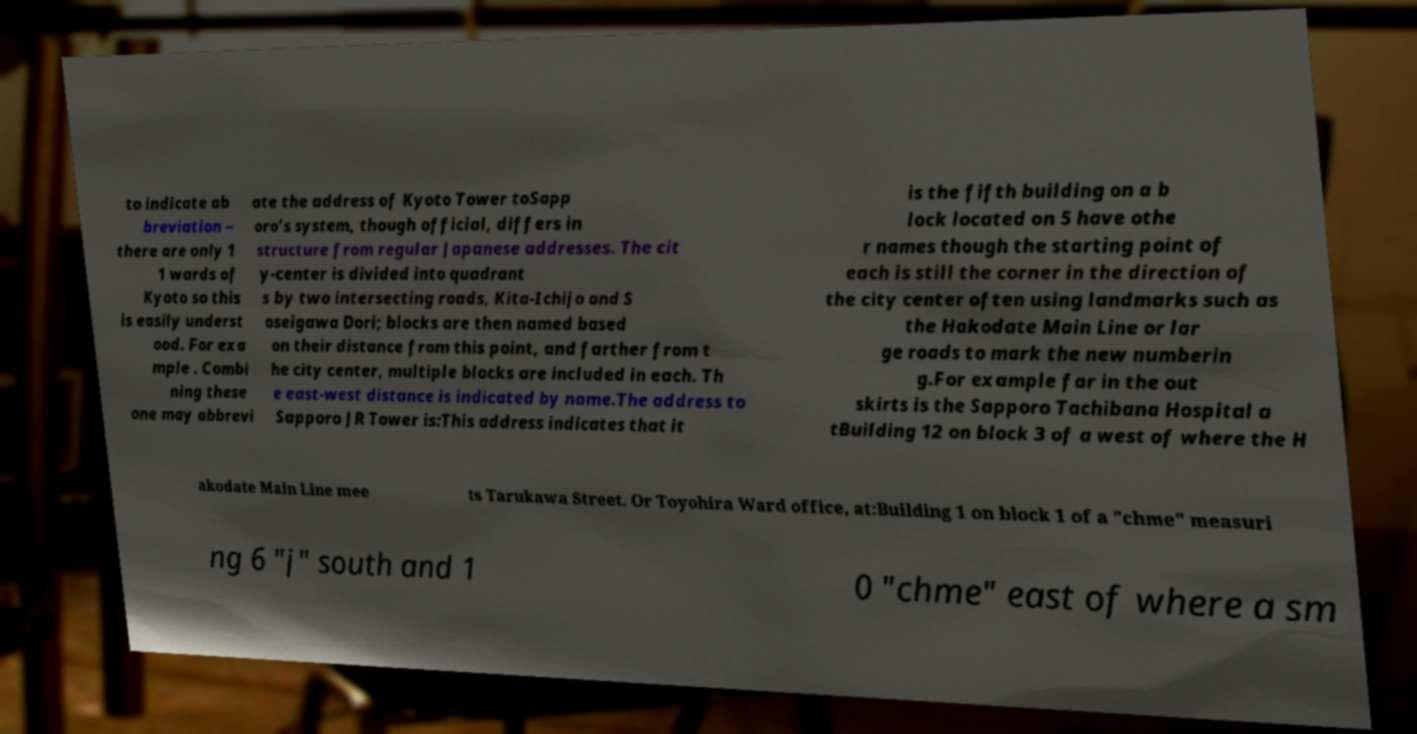Can you read and provide the text displayed in the image?This photo seems to have some interesting text. Can you extract and type it out for me? to indicate ab breviation – there are only 1 1 wards of Kyoto so this is easily underst ood. For exa mple . Combi ning these one may abbrevi ate the address of Kyoto Tower toSapp oro’s system, though official, differs in structure from regular Japanese addresses. The cit y-center is divided into quadrant s by two intersecting roads, Kita-Ichijo and S oseigawa Dori; blocks are then named based on their distance from this point, and farther from t he city center, multiple blocks are included in each. Th e east-west distance is indicated by name.The address to Sapporo JR Tower is:This address indicates that it is the fifth building on a b lock located on 5 have othe r names though the starting point of each is still the corner in the direction of the city center often using landmarks such as the Hakodate Main Line or lar ge roads to mark the new numberin g.For example far in the out skirts is the Sapporo Tachibana Hospital a tBuilding 12 on block 3 of a west of where the H akodate Main Line mee ts Tarukawa Street. Or Toyohira Ward office, at:Building 1 on block 1 of a "chme" measuri ng 6 "j" south and 1 0 "chme" east of where a sm 